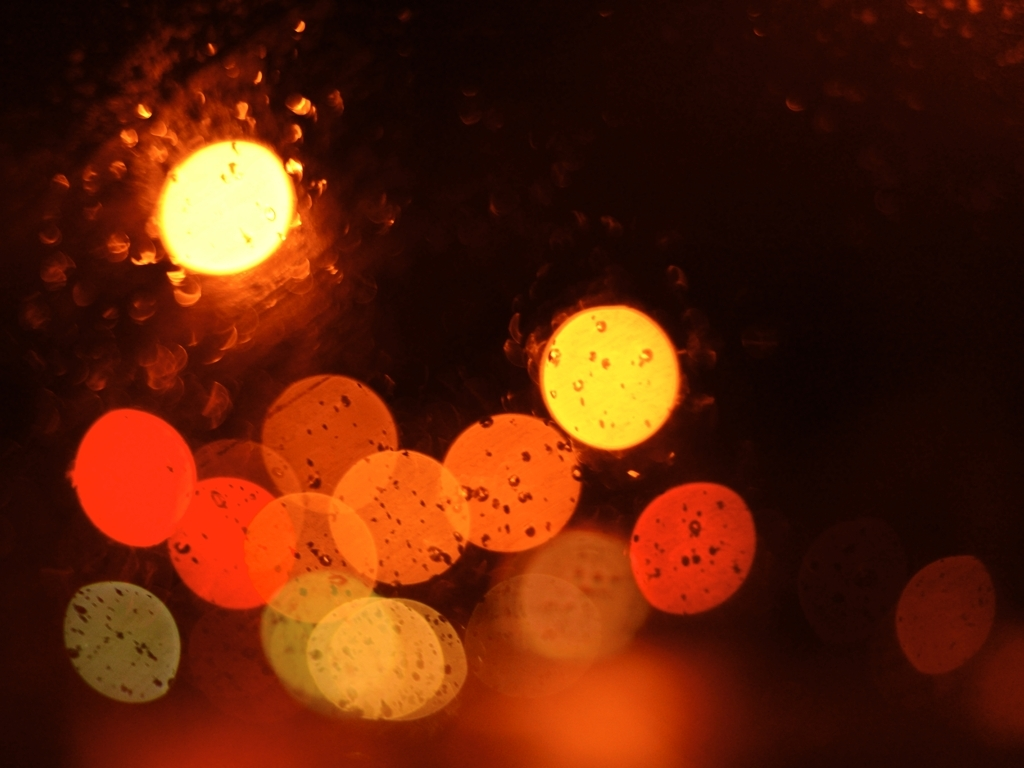Are there any quality issues with this image? Yes, the image appears to have a shallow depth of field resulting in a bokeh effect, where the light sources are blurred into large, colorful circles. This effect can be aesthetically pleasing, but it does compromise the sharpness of the details in the image. The presence of raindrops or moisture on the camera lens or window also adds texture to the photo but further obscures clear details. 